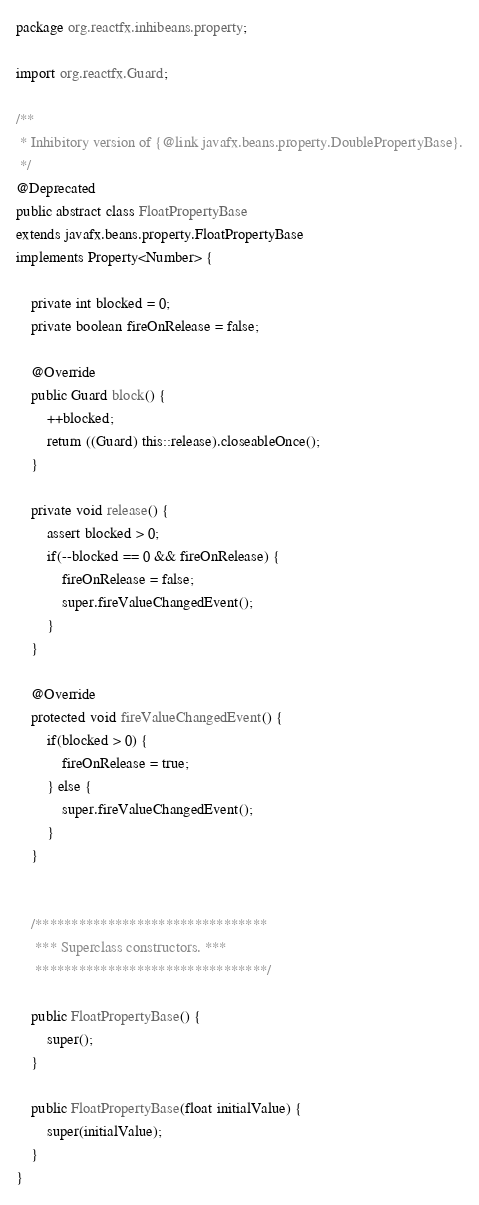<code> <loc_0><loc_0><loc_500><loc_500><_Java_>package org.reactfx.inhibeans.property;

import org.reactfx.Guard;

/**
 * Inhibitory version of {@link javafx.beans.property.DoublePropertyBase}.
 */
@Deprecated
public abstract class FloatPropertyBase
extends javafx.beans.property.FloatPropertyBase
implements Property<Number> {

    private int blocked = 0;
    private boolean fireOnRelease = false;

    @Override
    public Guard block() {
        ++blocked;
        return ((Guard) this::release).closeableOnce();
    }

    private void release() {
        assert blocked > 0;
        if(--blocked == 0 && fireOnRelease) {
            fireOnRelease = false;
            super.fireValueChangedEvent();
        }
    }

    @Override
    protected void fireValueChangedEvent() {
        if(blocked > 0) {
            fireOnRelease = true;
        } else {
            super.fireValueChangedEvent();
        }
    }


    /********************************
     *** Superclass constructors. ***
     ********************************/

    public FloatPropertyBase() {
        super();
    }

    public FloatPropertyBase(float initialValue) {
        super(initialValue);
    }
}
</code> 